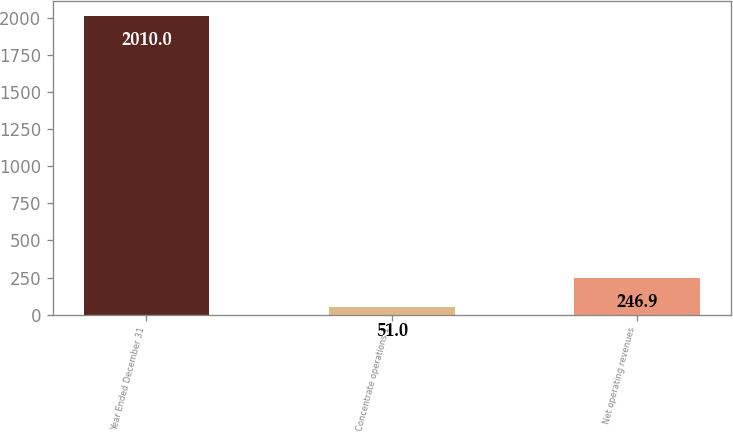Convert chart to OTSL. <chart><loc_0><loc_0><loc_500><loc_500><bar_chart><fcel>Year Ended December 31<fcel>Concentrate operations 1<fcel>Net operating revenues<nl><fcel>2010<fcel>51<fcel>246.9<nl></chart> 